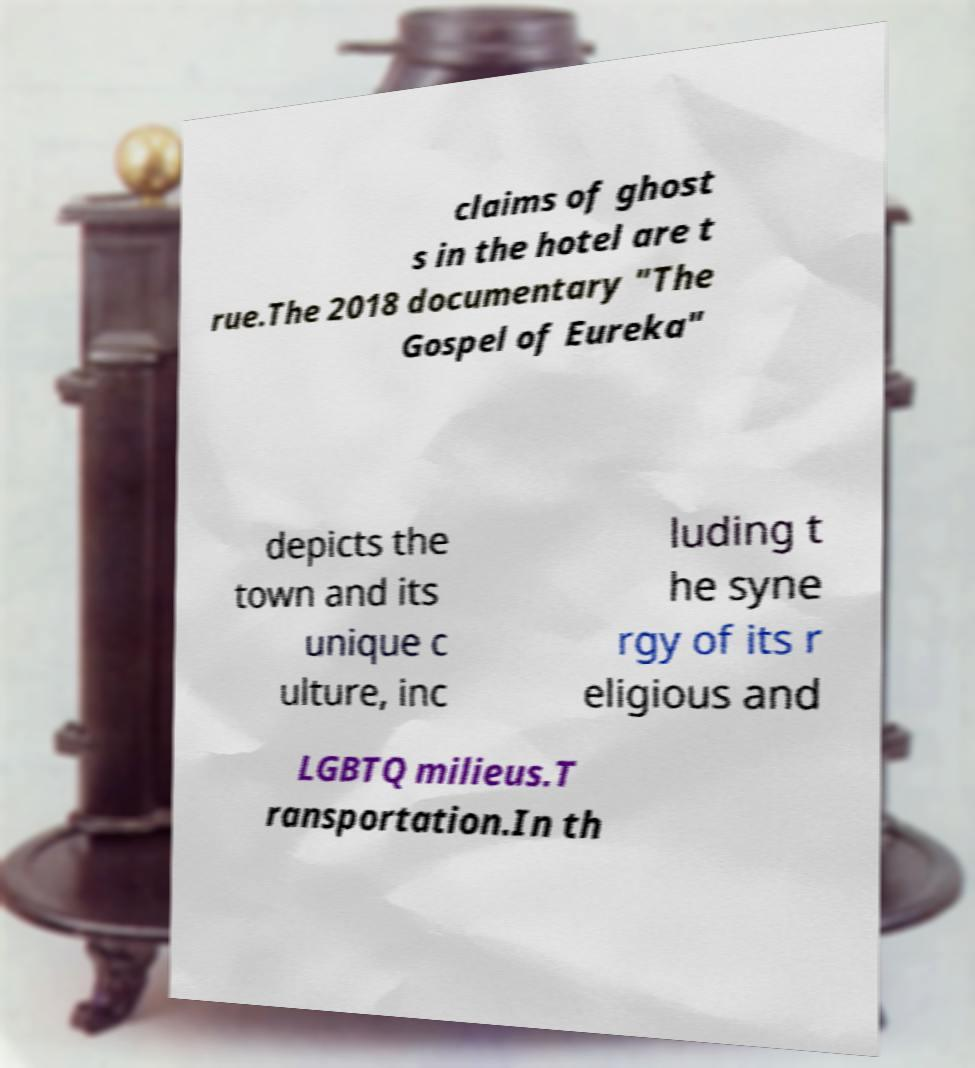There's text embedded in this image that I need extracted. Can you transcribe it verbatim? claims of ghost s in the hotel are t rue.The 2018 documentary "The Gospel of Eureka" depicts the town and its unique c ulture, inc luding t he syne rgy of its r eligious and LGBTQ milieus.T ransportation.In th 